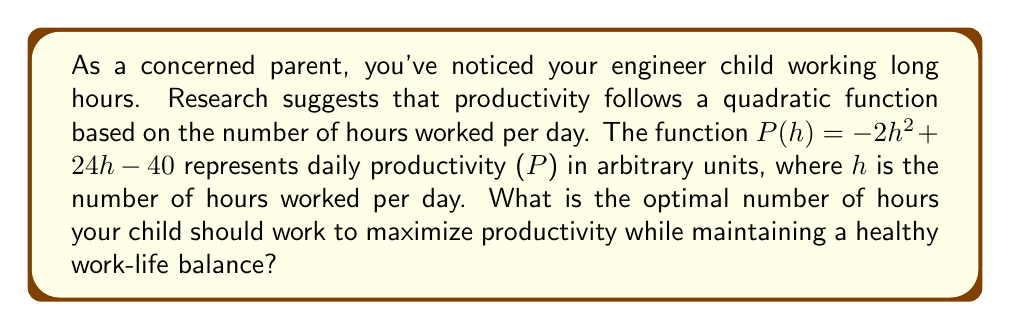Can you answer this question? To solve this problem, we need to find the maximum point of the quadratic function. The steps are as follows:

1) The quadratic function is in the form $P(h) = -2h^2 + 24h - 40$, which can be written as $P(h) = a(h^2) + b(h) + c$, where $a = -2$, $b = 24$, and $c = -40$.

2) For a quadratic function, the h-coordinate of the vertex (which represents the optimal number of hours for maximum productivity) is given by the formula:

   $h = -\frac{b}{2a}$

3) Substituting the values:

   $h = -\frac{24}{2(-2)} = -\frac{24}{-4} = 6$

4) To verify this is a maximum (not a minimum), we check that $a < 0$, which it is ($a = -2$).

5) Therefore, the optimal number of hours to work is 6.

This result suggests that working 6 hours per day would maximize productivity while allowing for a better work-life balance. It's important to note that this is a simplified model and real-world productivity can depend on many factors, but it provides a good starting point for discussion about work hours and productivity.
Answer: The optimal number of hours to work for maximum productivity is 6 hours. 